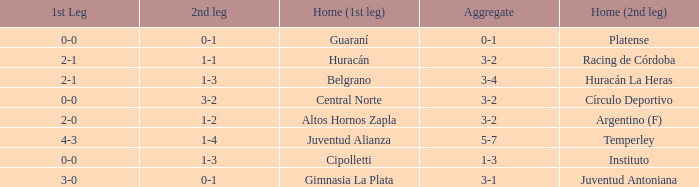Who played at home for the second leg with a score of 0-1 and tied 0-0 in the first leg? Platense. 